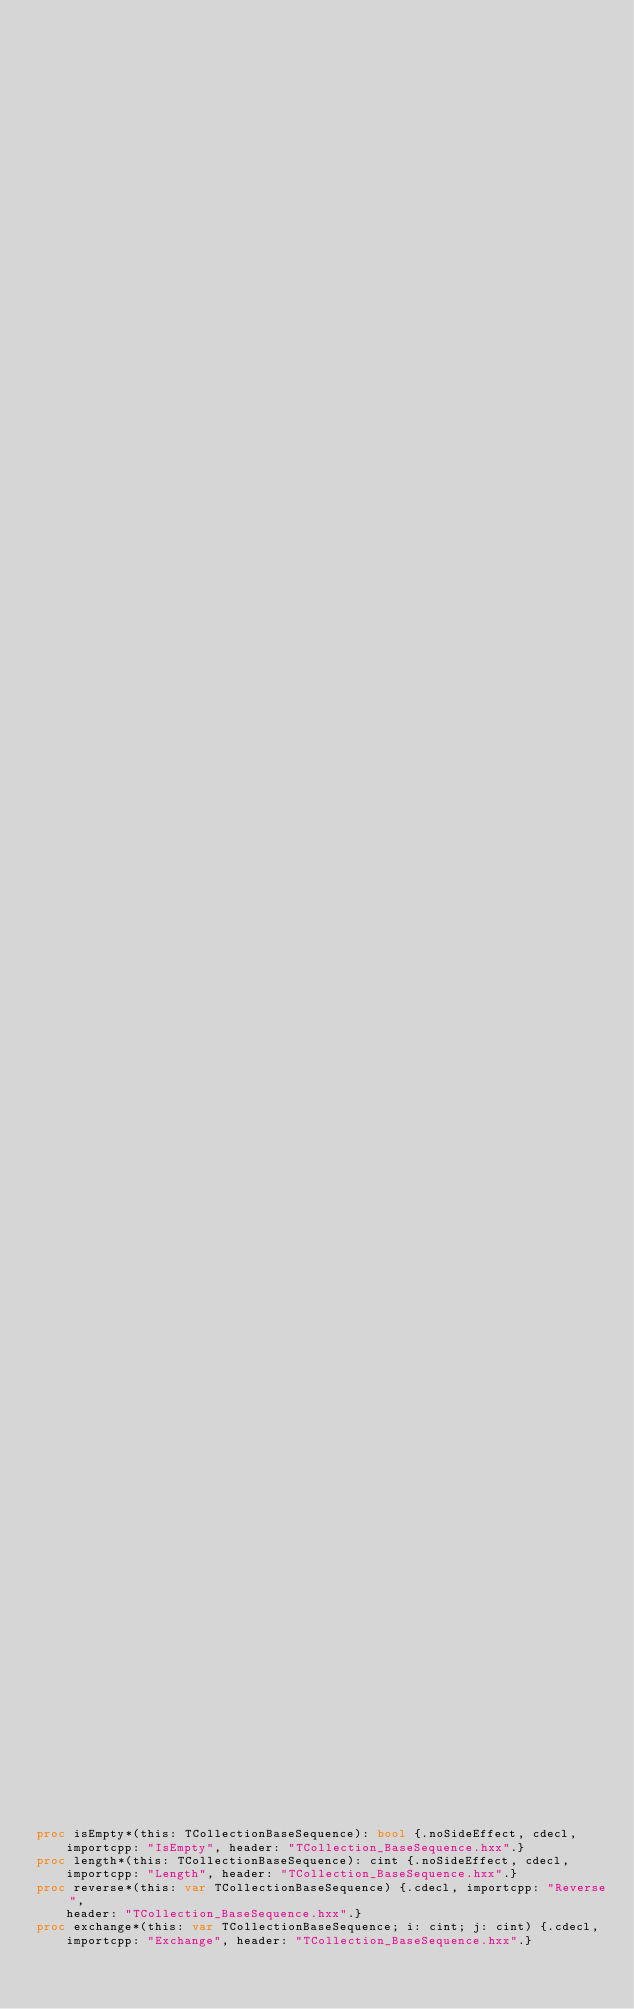<code> <loc_0><loc_0><loc_500><loc_500><_Nim_>                                                                                 ## sequence.
                                                                                 ##
                                                                                 ## !
                                                                                 ## Creation
                                                                                 ## by
                                                                                 ## copy
                                                                                 ## of
                                                                                 ## existing
                                                                                 ## Sequence.
                                                                                 ##
                                                                                 ## !
                                                                                 ## Warning:
                                                                                 ## This
                                                                                 ## constructor
                                                                                 ## prints
                                                                                 ## a
                                                                                 ## warning
                                                                                 ## message.
                                                                                 ##
                                                                                 ## !
                                                                                 ## We
                                                                                 ## recommand
                                                                                 ## to
                                                                                 ## use
                                                                                 ## the
                                                                                 ## operator
                                                                                 ## =.


proc isEmpty*(this: TCollectionBaseSequence): bool {.noSideEffect, cdecl,
    importcpp: "IsEmpty", header: "TCollection_BaseSequence.hxx".}
proc length*(this: TCollectionBaseSequence): cint {.noSideEffect, cdecl,
    importcpp: "Length", header: "TCollection_BaseSequence.hxx".}
proc reverse*(this: var TCollectionBaseSequence) {.cdecl, importcpp: "Reverse",
    header: "TCollection_BaseSequence.hxx".}
proc exchange*(this: var TCollectionBaseSequence; i: cint; j: cint) {.cdecl,
    importcpp: "Exchange", header: "TCollection_BaseSequence.hxx".}</code> 